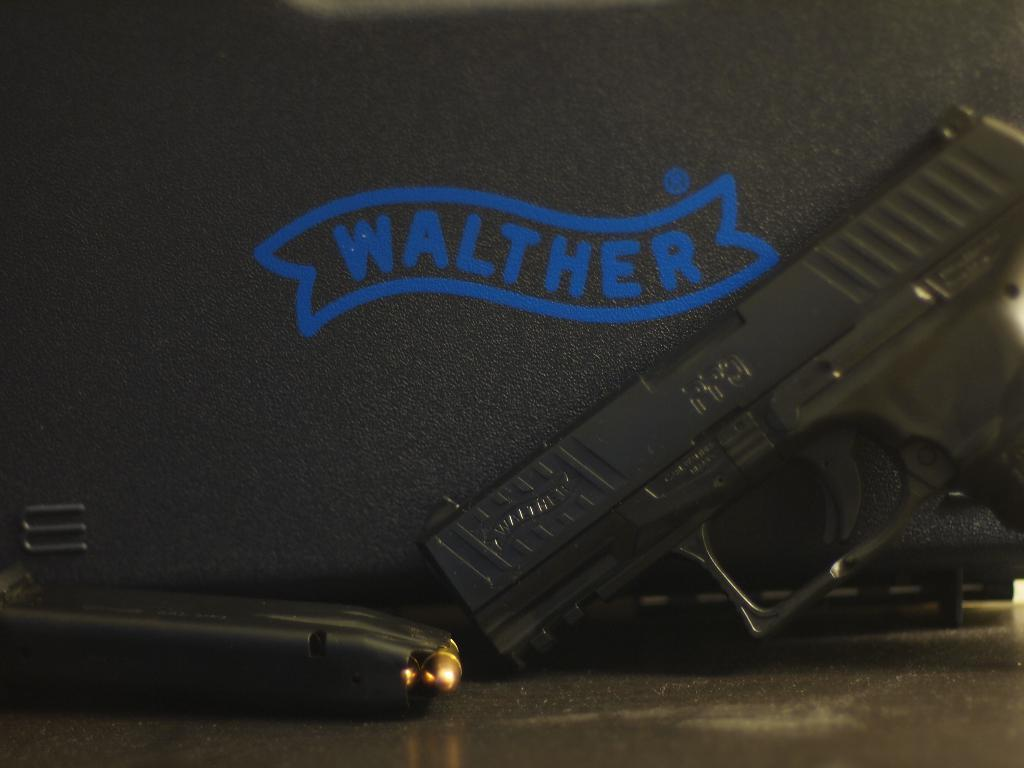What object in the image is typically used for self-defense or hunting? There is a gun in the image, which is typically used for self-defense or hunting. What can be found inside the gun? There is a magazine in the image, which is likely to contain ammunition for the gun. What else is present in the image besides the gun and magazine? There is text in the image, which could be instructions, warnings, or other information related to the gun or magazine. Can you see a snake sneezing under the arch in the image? There is no snake, sneezing, or arch present in the image. 